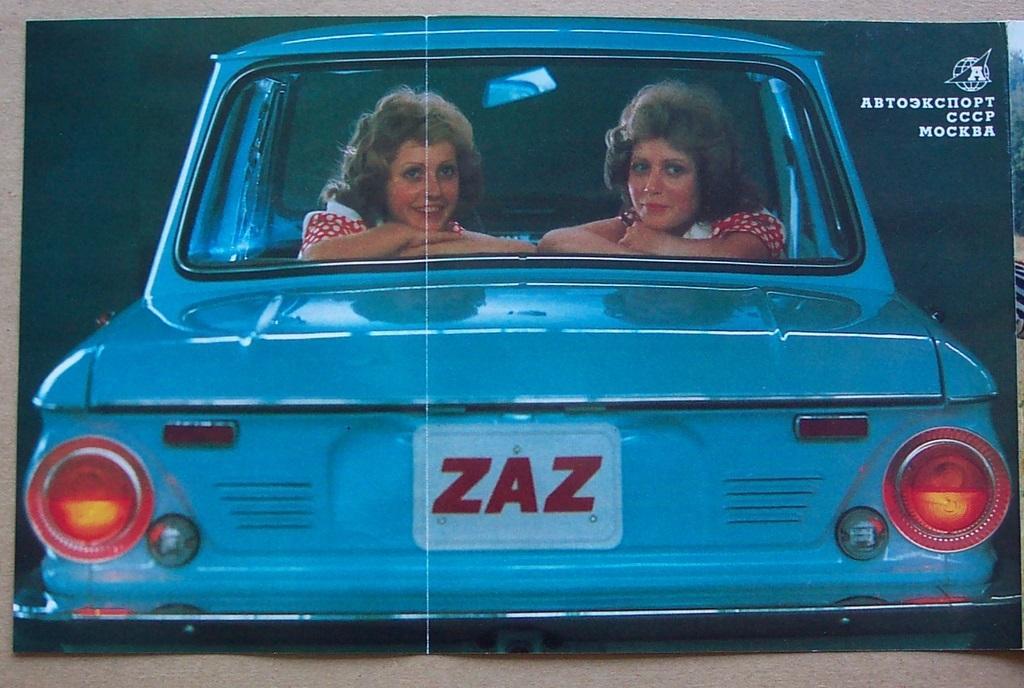How would you summarize this image in a sentence or two? 2 women are sitting in a blue car. on the registration plate zazn is written. 